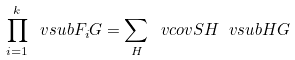Convert formula to latex. <formula><loc_0><loc_0><loc_500><loc_500>\prod _ { i = 1 } ^ { k } \ v s u b { F _ { i } } { G } = \sum _ { H } \ v c o v { S } { H } \ v s u b { H } { G }</formula> 